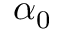Convert formula to latex. <formula><loc_0><loc_0><loc_500><loc_500>\alpha _ { 0 }</formula> 